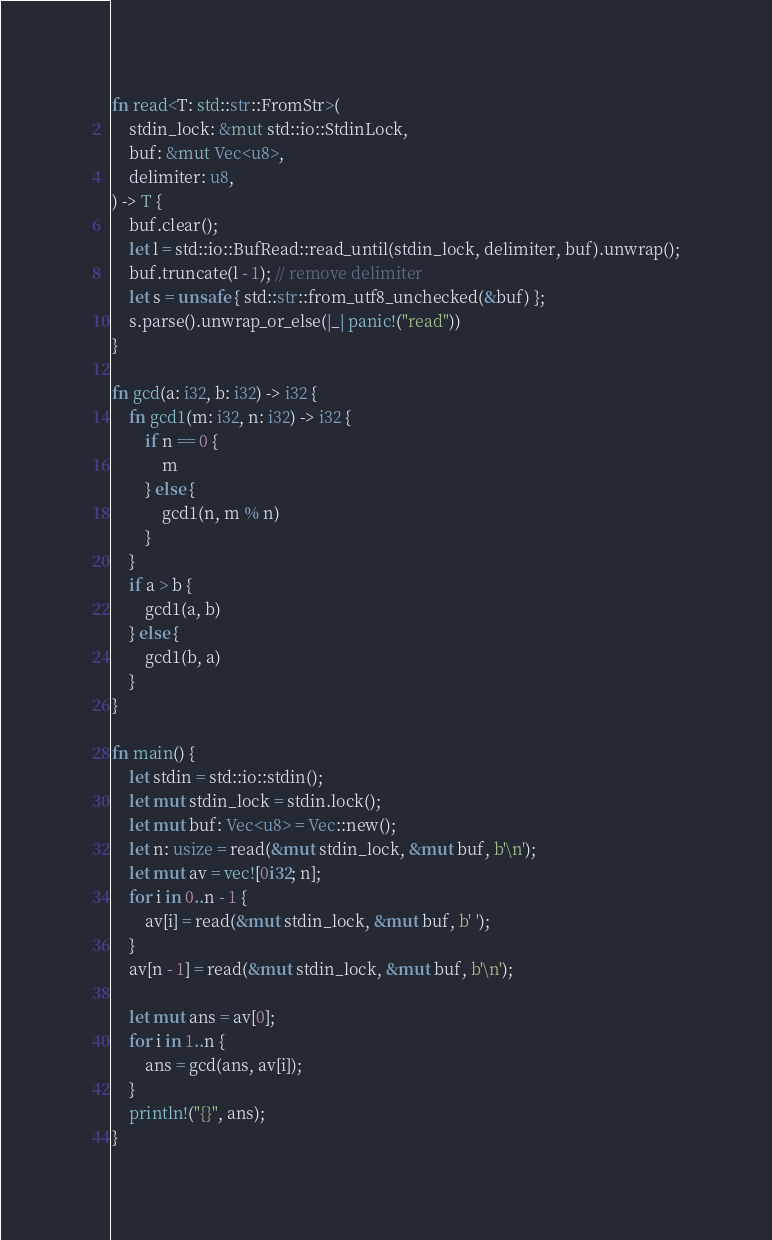<code> <loc_0><loc_0><loc_500><loc_500><_Rust_>fn read<T: std::str::FromStr>(
    stdin_lock: &mut std::io::StdinLock,
    buf: &mut Vec<u8>,
    delimiter: u8,
) -> T {
    buf.clear();
    let l = std::io::BufRead::read_until(stdin_lock, delimiter, buf).unwrap();
    buf.truncate(l - 1); // remove delimiter
    let s = unsafe { std::str::from_utf8_unchecked(&buf) };
    s.parse().unwrap_or_else(|_| panic!("read"))
}

fn gcd(a: i32, b: i32) -> i32 {
    fn gcd1(m: i32, n: i32) -> i32 {
        if n == 0 {
            m
        } else {
            gcd1(n, m % n)
        }
    }
    if a > b {
        gcd1(a, b)
    } else {
        gcd1(b, a)
    }
}

fn main() {
    let stdin = std::io::stdin();
    let mut stdin_lock = stdin.lock();
    let mut buf: Vec<u8> = Vec::new();
    let n: usize = read(&mut stdin_lock, &mut buf, b'\n');
    let mut av = vec![0i32; n];
    for i in 0..n - 1 {
        av[i] = read(&mut stdin_lock, &mut buf, b' ');
    }
    av[n - 1] = read(&mut stdin_lock, &mut buf, b'\n');

    let mut ans = av[0];
    for i in 1..n {
        ans = gcd(ans, av[i]);
    }
    println!("{}", ans);
}
</code> 